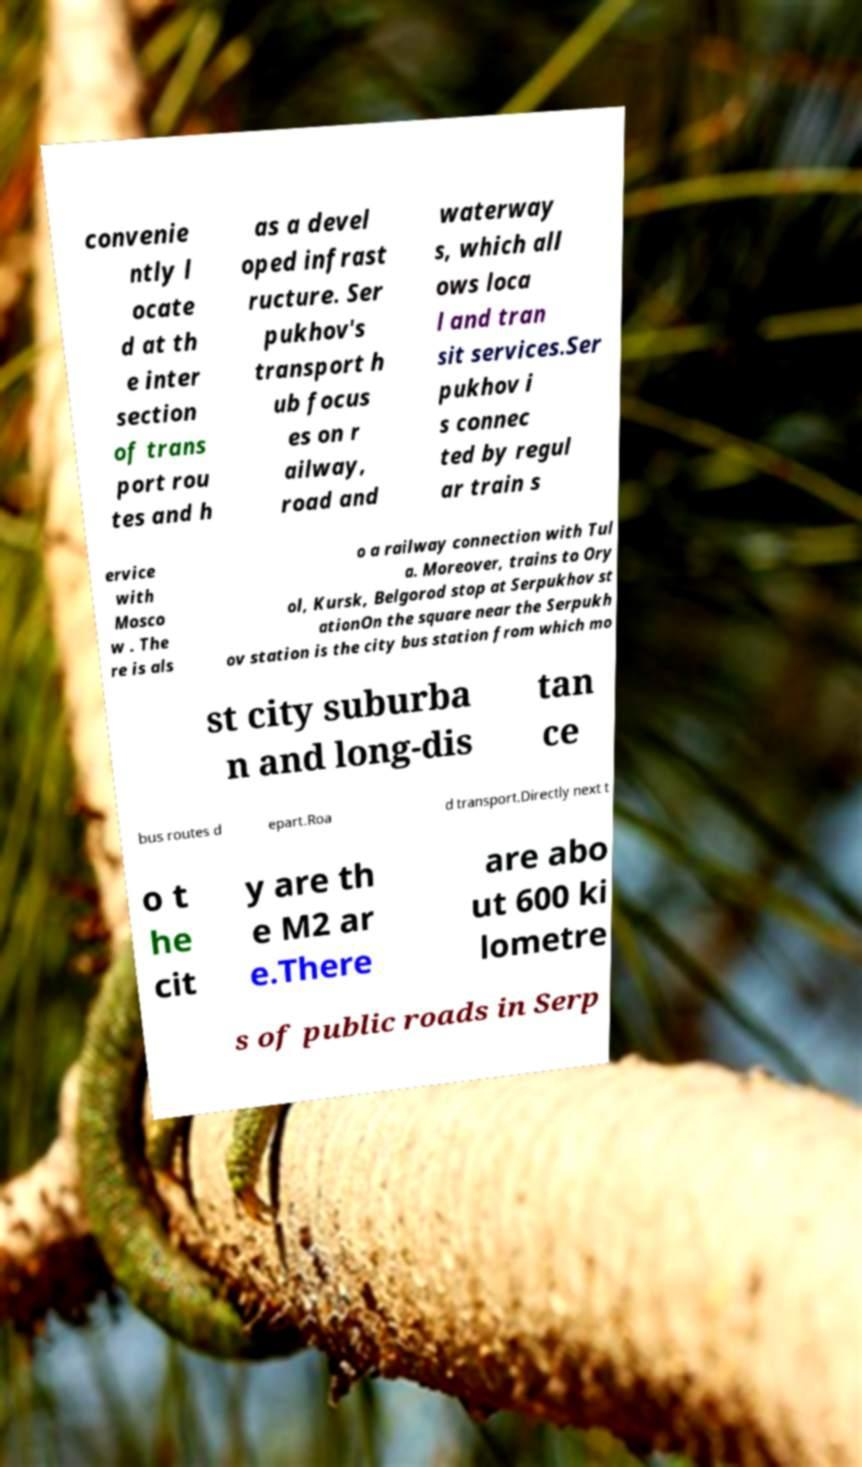For documentation purposes, I need the text within this image transcribed. Could you provide that? convenie ntly l ocate d at th e inter section of trans port rou tes and h as a devel oped infrast ructure. Ser pukhov's transport h ub focus es on r ailway, road and waterway s, which all ows loca l and tran sit services.Ser pukhov i s connec ted by regul ar train s ervice with Mosco w . The re is als o a railway connection with Tul a. Moreover, trains to Ory ol, Kursk, Belgorod stop at Serpukhov st ationOn the square near the Serpukh ov station is the city bus station from which mo st city suburba n and long-dis tan ce bus routes d epart.Roa d transport.Directly next t o t he cit y are th e M2 ar e.There are abo ut 600 ki lometre s of public roads in Serp 